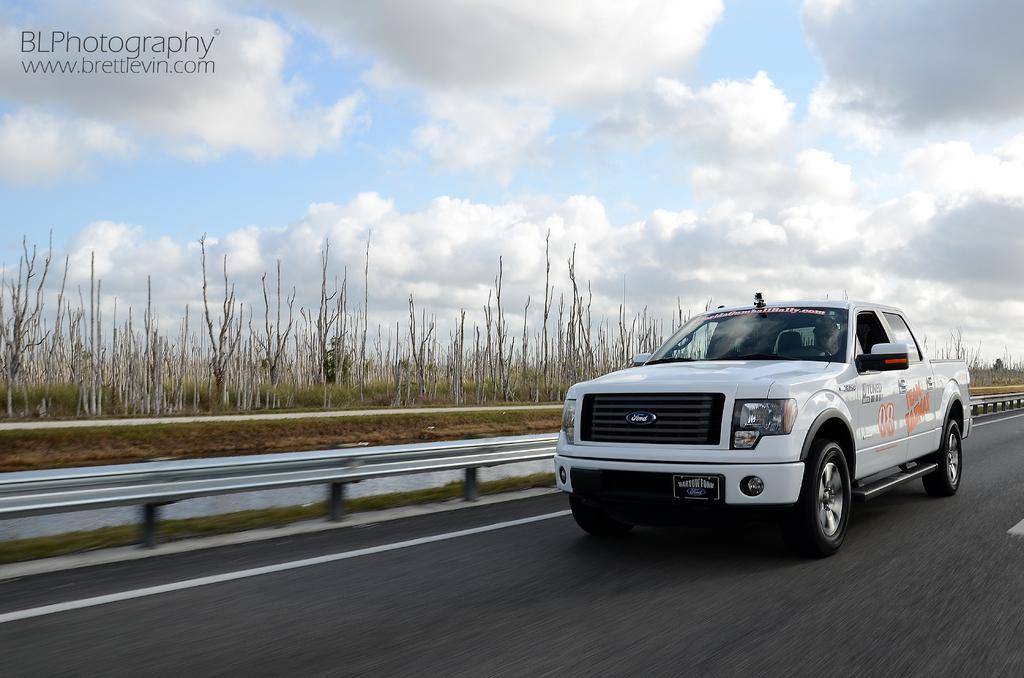Describe this image in one or two sentences. In this picture I can see the man who is riding a white color car on the road. Beside that I can see the road fencing. In the background I can see the trees, plants and grass. At the top I can see the sky and clouds. In the bottom left corner I can see the watermark. 